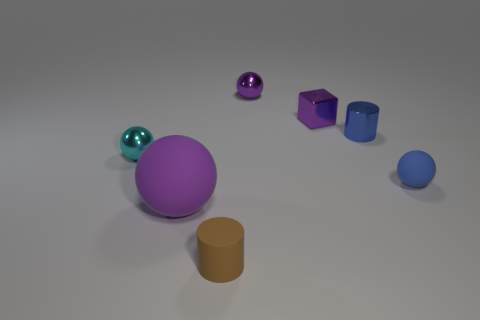Do the small matte thing that is left of the blue rubber ball and the tiny cyan thing have the same shape?
Make the answer very short. No. Is there a small cyan metallic object that has the same shape as the tiny blue matte thing?
Your answer should be very brief. Yes. What material is the tiny object that is the same color as the small shiny cylinder?
Provide a succinct answer. Rubber. There is a small matte object that is behind the large rubber object that is on the left side of the tiny brown rubber thing; what shape is it?
Provide a succinct answer. Sphere. How many brown things have the same material as the large purple thing?
Ensure brevity in your answer.  1. The block that is the same material as the small blue cylinder is what color?
Your response must be concise. Purple. There is a ball that is on the left side of the purple thing that is in front of the small ball that is to the left of the small brown object; what size is it?
Your answer should be compact. Small. Are there fewer large rubber objects than tiny rubber things?
Your response must be concise. Yes. The large thing that is the same shape as the small blue rubber object is what color?
Your response must be concise. Purple. There is a small object that is in front of the purple thing that is to the left of the tiny brown object; is there a tiny matte object that is to the right of it?
Offer a terse response. Yes. 